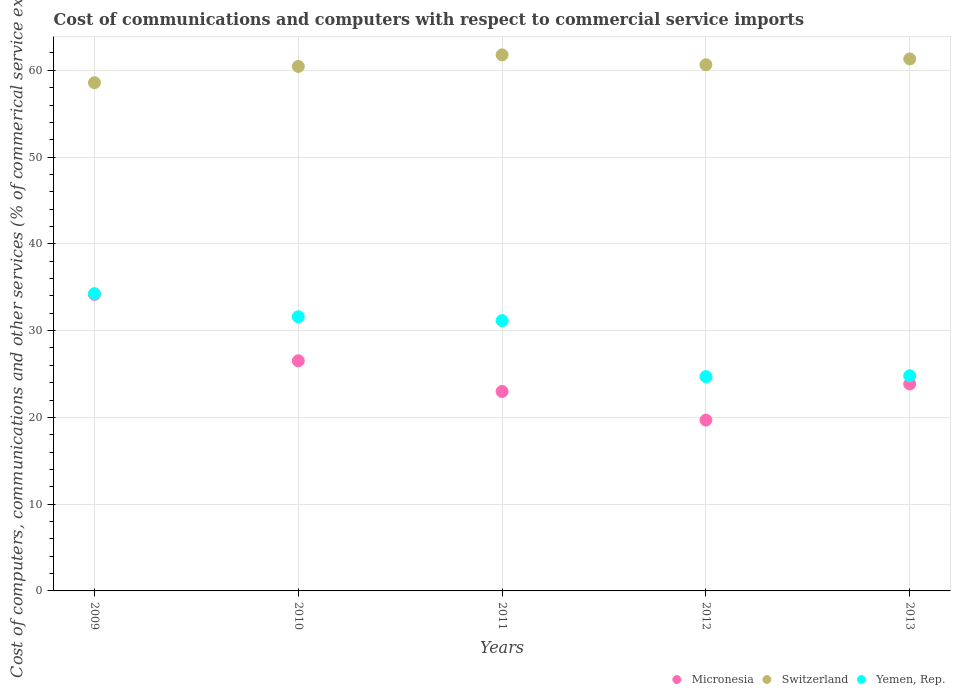How many different coloured dotlines are there?
Provide a short and direct response. 3. What is the cost of communications and computers in Yemen, Rep. in 2013?
Give a very brief answer. 24.8. Across all years, what is the maximum cost of communications and computers in Micronesia?
Offer a very short reply. 34.18. Across all years, what is the minimum cost of communications and computers in Micronesia?
Offer a very short reply. 19.69. In which year was the cost of communications and computers in Switzerland minimum?
Make the answer very short. 2009. What is the total cost of communications and computers in Micronesia in the graph?
Give a very brief answer. 127.21. What is the difference between the cost of communications and computers in Yemen, Rep. in 2009 and that in 2010?
Provide a succinct answer. 2.66. What is the difference between the cost of communications and computers in Switzerland in 2013 and the cost of communications and computers in Micronesia in 2010?
Offer a terse response. 34.79. What is the average cost of communications and computers in Micronesia per year?
Provide a short and direct response. 25.44. In the year 2010, what is the difference between the cost of communications and computers in Micronesia and cost of communications and computers in Yemen, Rep.?
Provide a short and direct response. -5.08. What is the ratio of the cost of communications and computers in Micronesia in 2011 to that in 2013?
Offer a very short reply. 0.96. What is the difference between the highest and the second highest cost of communications and computers in Switzerland?
Your answer should be compact. 0.47. What is the difference between the highest and the lowest cost of communications and computers in Yemen, Rep.?
Keep it short and to the point. 9.56. In how many years, is the cost of communications and computers in Yemen, Rep. greater than the average cost of communications and computers in Yemen, Rep. taken over all years?
Ensure brevity in your answer.  3. Is the cost of communications and computers in Switzerland strictly greater than the cost of communications and computers in Micronesia over the years?
Keep it short and to the point. Yes. Is the cost of communications and computers in Micronesia strictly less than the cost of communications and computers in Switzerland over the years?
Provide a short and direct response. Yes. How many years are there in the graph?
Your answer should be compact. 5. Are the values on the major ticks of Y-axis written in scientific E-notation?
Your answer should be compact. No. Does the graph contain grids?
Your answer should be compact. Yes. Where does the legend appear in the graph?
Provide a succinct answer. Bottom right. How are the legend labels stacked?
Make the answer very short. Horizontal. What is the title of the graph?
Your answer should be very brief. Cost of communications and computers with respect to commercial service imports. What is the label or title of the X-axis?
Keep it short and to the point. Years. What is the label or title of the Y-axis?
Your answer should be compact. Cost of computers, communications and other services (% of commerical service exports). What is the Cost of computers, communications and other services (% of commerical service exports) of Micronesia in 2009?
Provide a short and direct response. 34.18. What is the Cost of computers, communications and other services (% of commerical service exports) in Switzerland in 2009?
Offer a terse response. 58.57. What is the Cost of computers, communications and other services (% of commerical service exports) of Yemen, Rep. in 2009?
Ensure brevity in your answer.  34.26. What is the Cost of computers, communications and other services (% of commerical service exports) of Micronesia in 2010?
Your answer should be very brief. 26.52. What is the Cost of computers, communications and other services (% of commerical service exports) in Switzerland in 2010?
Your answer should be very brief. 60.44. What is the Cost of computers, communications and other services (% of commerical service exports) in Yemen, Rep. in 2010?
Your response must be concise. 31.6. What is the Cost of computers, communications and other services (% of commerical service exports) of Micronesia in 2011?
Your response must be concise. 22.98. What is the Cost of computers, communications and other services (% of commerical service exports) of Switzerland in 2011?
Offer a terse response. 61.78. What is the Cost of computers, communications and other services (% of commerical service exports) in Yemen, Rep. in 2011?
Provide a short and direct response. 31.15. What is the Cost of computers, communications and other services (% of commerical service exports) in Micronesia in 2012?
Ensure brevity in your answer.  19.69. What is the Cost of computers, communications and other services (% of commerical service exports) of Switzerland in 2012?
Keep it short and to the point. 60.64. What is the Cost of computers, communications and other services (% of commerical service exports) in Yemen, Rep. in 2012?
Provide a short and direct response. 24.7. What is the Cost of computers, communications and other services (% of commerical service exports) in Micronesia in 2013?
Your response must be concise. 23.84. What is the Cost of computers, communications and other services (% of commerical service exports) in Switzerland in 2013?
Make the answer very short. 61.31. What is the Cost of computers, communications and other services (% of commerical service exports) of Yemen, Rep. in 2013?
Offer a terse response. 24.8. Across all years, what is the maximum Cost of computers, communications and other services (% of commerical service exports) in Micronesia?
Your response must be concise. 34.18. Across all years, what is the maximum Cost of computers, communications and other services (% of commerical service exports) in Switzerland?
Provide a short and direct response. 61.78. Across all years, what is the maximum Cost of computers, communications and other services (% of commerical service exports) of Yemen, Rep.?
Your response must be concise. 34.26. Across all years, what is the minimum Cost of computers, communications and other services (% of commerical service exports) in Micronesia?
Offer a very short reply. 19.69. Across all years, what is the minimum Cost of computers, communications and other services (% of commerical service exports) of Switzerland?
Offer a terse response. 58.57. Across all years, what is the minimum Cost of computers, communications and other services (% of commerical service exports) of Yemen, Rep.?
Give a very brief answer. 24.7. What is the total Cost of computers, communications and other services (% of commerical service exports) in Micronesia in the graph?
Your response must be concise. 127.21. What is the total Cost of computers, communications and other services (% of commerical service exports) of Switzerland in the graph?
Your answer should be very brief. 302.74. What is the total Cost of computers, communications and other services (% of commerical service exports) in Yemen, Rep. in the graph?
Offer a terse response. 146.49. What is the difference between the Cost of computers, communications and other services (% of commerical service exports) in Micronesia in 2009 and that in 2010?
Give a very brief answer. 7.65. What is the difference between the Cost of computers, communications and other services (% of commerical service exports) of Switzerland in 2009 and that in 2010?
Keep it short and to the point. -1.88. What is the difference between the Cost of computers, communications and other services (% of commerical service exports) of Yemen, Rep. in 2009 and that in 2010?
Provide a short and direct response. 2.66. What is the difference between the Cost of computers, communications and other services (% of commerical service exports) of Micronesia in 2009 and that in 2011?
Provide a short and direct response. 11.19. What is the difference between the Cost of computers, communications and other services (% of commerical service exports) in Switzerland in 2009 and that in 2011?
Ensure brevity in your answer.  -3.21. What is the difference between the Cost of computers, communications and other services (% of commerical service exports) in Yemen, Rep. in 2009 and that in 2011?
Your response must be concise. 3.11. What is the difference between the Cost of computers, communications and other services (% of commerical service exports) of Micronesia in 2009 and that in 2012?
Your answer should be very brief. 14.49. What is the difference between the Cost of computers, communications and other services (% of commerical service exports) in Switzerland in 2009 and that in 2012?
Offer a very short reply. -2.07. What is the difference between the Cost of computers, communications and other services (% of commerical service exports) in Yemen, Rep. in 2009 and that in 2012?
Keep it short and to the point. 9.56. What is the difference between the Cost of computers, communications and other services (% of commerical service exports) in Micronesia in 2009 and that in 2013?
Provide a succinct answer. 10.33. What is the difference between the Cost of computers, communications and other services (% of commerical service exports) in Switzerland in 2009 and that in 2013?
Give a very brief answer. -2.74. What is the difference between the Cost of computers, communications and other services (% of commerical service exports) in Yemen, Rep. in 2009 and that in 2013?
Provide a short and direct response. 9.46. What is the difference between the Cost of computers, communications and other services (% of commerical service exports) in Micronesia in 2010 and that in 2011?
Keep it short and to the point. 3.54. What is the difference between the Cost of computers, communications and other services (% of commerical service exports) of Switzerland in 2010 and that in 2011?
Provide a short and direct response. -1.34. What is the difference between the Cost of computers, communications and other services (% of commerical service exports) in Yemen, Rep. in 2010 and that in 2011?
Give a very brief answer. 0.45. What is the difference between the Cost of computers, communications and other services (% of commerical service exports) of Micronesia in 2010 and that in 2012?
Your response must be concise. 6.83. What is the difference between the Cost of computers, communications and other services (% of commerical service exports) of Switzerland in 2010 and that in 2012?
Your answer should be compact. -0.2. What is the difference between the Cost of computers, communications and other services (% of commerical service exports) in Yemen, Rep. in 2010 and that in 2012?
Ensure brevity in your answer.  6.9. What is the difference between the Cost of computers, communications and other services (% of commerical service exports) in Micronesia in 2010 and that in 2013?
Provide a short and direct response. 2.68. What is the difference between the Cost of computers, communications and other services (% of commerical service exports) in Switzerland in 2010 and that in 2013?
Keep it short and to the point. -0.86. What is the difference between the Cost of computers, communications and other services (% of commerical service exports) in Yemen, Rep. in 2010 and that in 2013?
Give a very brief answer. 6.8. What is the difference between the Cost of computers, communications and other services (% of commerical service exports) in Micronesia in 2011 and that in 2012?
Give a very brief answer. 3.3. What is the difference between the Cost of computers, communications and other services (% of commerical service exports) of Switzerland in 2011 and that in 2012?
Give a very brief answer. 1.14. What is the difference between the Cost of computers, communications and other services (% of commerical service exports) in Yemen, Rep. in 2011 and that in 2012?
Offer a terse response. 6.45. What is the difference between the Cost of computers, communications and other services (% of commerical service exports) in Micronesia in 2011 and that in 2013?
Offer a terse response. -0.86. What is the difference between the Cost of computers, communications and other services (% of commerical service exports) in Switzerland in 2011 and that in 2013?
Offer a very short reply. 0.47. What is the difference between the Cost of computers, communications and other services (% of commerical service exports) in Yemen, Rep. in 2011 and that in 2013?
Offer a terse response. 6.35. What is the difference between the Cost of computers, communications and other services (% of commerical service exports) in Micronesia in 2012 and that in 2013?
Provide a short and direct response. -4.16. What is the difference between the Cost of computers, communications and other services (% of commerical service exports) in Switzerland in 2012 and that in 2013?
Your answer should be very brief. -0.67. What is the difference between the Cost of computers, communications and other services (% of commerical service exports) in Yemen, Rep. in 2012 and that in 2013?
Your answer should be compact. -0.1. What is the difference between the Cost of computers, communications and other services (% of commerical service exports) of Micronesia in 2009 and the Cost of computers, communications and other services (% of commerical service exports) of Switzerland in 2010?
Ensure brevity in your answer.  -26.27. What is the difference between the Cost of computers, communications and other services (% of commerical service exports) in Micronesia in 2009 and the Cost of computers, communications and other services (% of commerical service exports) in Yemen, Rep. in 2010?
Provide a succinct answer. 2.58. What is the difference between the Cost of computers, communications and other services (% of commerical service exports) in Switzerland in 2009 and the Cost of computers, communications and other services (% of commerical service exports) in Yemen, Rep. in 2010?
Offer a very short reply. 26.97. What is the difference between the Cost of computers, communications and other services (% of commerical service exports) of Micronesia in 2009 and the Cost of computers, communications and other services (% of commerical service exports) of Switzerland in 2011?
Your response must be concise. -27.61. What is the difference between the Cost of computers, communications and other services (% of commerical service exports) in Micronesia in 2009 and the Cost of computers, communications and other services (% of commerical service exports) in Yemen, Rep. in 2011?
Your response must be concise. 3.03. What is the difference between the Cost of computers, communications and other services (% of commerical service exports) of Switzerland in 2009 and the Cost of computers, communications and other services (% of commerical service exports) of Yemen, Rep. in 2011?
Provide a short and direct response. 27.42. What is the difference between the Cost of computers, communications and other services (% of commerical service exports) in Micronesia in 2009 and the Cost of computers, communications and other services (% of commerical service exports) in Switzerland in 2012?
Offer a very short reply. -26.46. What is the difference between the Cost of computers, communications and other services (% of commerical service exports) in Micronesia in 2009 and the Cost of computers, communications and other services (% of commerical service exports) in Yemen, Rep. in 2012?
Your answer should be compact. 9.48. What is the difference between the Cost of computers, communications and other services (% of commerical service exports) of Switzerland in 2009 and the Cost of computers, communications and other services (% of commerical service exports) of Yemen, Rep. in 2012?
Ensure brevity in your answer.  33.87. What is the difference between the Cost of computers, communications and other services (% of commerical service exports) of Micronesia in 2009 and the Cost of computers, communications and other services (% of commerical service exports) of Switzerland in 2013?
Your response must be concise. -27.13. What is the difference between the Cost of computers, communications and other services (% of commerical service exports) in Micronesia in 2009 and the Cost of computers, communications and other services (% of commerical service exports) in Yemen, Rep. in 2013?
Keep it short and to the point. 9.38. What is the difference between the Cost of computers, communications and other services (% of commerical service exports) in Switzerland in 2009 and the Cost of computers, communications and other services (% of commerical service exports) in Yemen, Rep. in 2013?
Give a very brief answer. 33.77. What is the difference between the Cost of computers, communications and other services (% of commerical service exports) of Micronesia in 2010 and the Cost of computers, communications and other services (% of commerical service exports) of Switzerland in 2011?
Provide a short and direct response. -35.26. What is the difference between the Cost of computers, communications and other services (% of commerical service exports) in Micronesia in 2010 and the Cost of computers, communications and other services (% of commerical service exports) in Yemen, Rep. in 2011?
Offer a very short reply. -4.63. What is the difference between the Cost of computers, communications and other services (% of commerical service exports) of Switzerland in 2010 and the Cost of computers, communications and other services (% of commerical service exports) of Yemen, Rep. in 2011?
Keep it short and to the point. 29.3. What is the difference between the Cost of computers, communications and other services (% of commerical service exports) in Micronesia in 2010 and the Cost of computers, communications and other services (% of commerical service exports) in Switzerland in 2012?
Give a very brief answer. -34.12. What is the difference between the Cost of computers, communications and other services (% of commerical service exports) in Micronesia in 2010 and the Cost of computers, communications and other services (% of commerical service exports) in Yemen, Rep. in 2012?
Provide a short and direct response. 1.83. What is the difference between the Cost of computers, communications and other services (% of commerical service exports) in Switzerland in 2010 and the Cost of computers, communications and other services (% of commerical service exports) in Yemen, Rep. in 2012?
Offer a very short reply. 35.75. What is the difference between the Cost of computers, communications and other services (% of commerical service exports) of Micronesia in 2010 and the Cost of computers, communications and other services (% of commerical service exports) of Switzerland in 2013?
Offer a terse response. -34.79. What is the difference between the Cost of computers, communications and other services (% of commerical service exports) in Micronesia in 2010 and the Cost of computers, communications and other services (% of commerical service exports) in Yemen, Rep. in 2013?
Keep it short and to the point. 1.72. What is the difference between the Cost of computers, communications and other services (% of commerical service exports) in Switzerland in 2010 and the Cost of computers, communications and other services (% of commerical service exports) in Yemen, Rep. in 2013?
Make the answer very short. 35.65. What is the difference between the Cost of computers, communications and other services (% of commerical service exports) in Micronesia in 2011 and the Cost of computers, communications and other services (% of commerical service exports) in Switzerland in 2012?
Offer a very short reply. -37.66. What is the difference between the Cost of computers, communications and other services (% of commerical service exports) in Micronesia in 2011 and the Cost of computers, communications and other services (% of commerical service exports) in Yemen, Rep. in 2012?
Provide a short and direct response. -1.71. What is the difference between the Cost of computers, communications and other services (% of commerical service exports) in Switzerland in 2011 and the Cost of computers, communications and other services (% of commerical service exports) in Yemen, Rep. in 2012?
Provide a short and direct response. 37.09. What is the difference between the Cost of computers, communications and other services (% of commerical service exports) in Micronesia in 2011 and the Cost of computers, communications and other services (% of commerical service exports) in Switzerland in 2013?
Keep it short and to the point. -38.32. What is the difference between the Cost of computers, communications and other services (% of commerical service exports) in Micronesia in 2011 and the Cost of computers, communications and other services (% of commerical service exports) in Yemen, Rep. in 2013?
Make the answer very short. -1.81. What is the difference between the Cost of computers, communications and other services (% of commerical service exports) in Switzerland in 2011 and the Cost of computers, communications and other services (% of commerical service exports) in Yemen, Rep. in 2013?
Ensure brevity in your answer.  36.98. What is the difference between the Cost of computers, communications and other services (% of commerical service exports) of Micronesia in 2012 and the Cost of computers, communications and other services (% of commerical service exports) of Switzerland in 2013?
Offer a very short reply. -41.62. What is the difference between the Cost of computers, communications and other services (% of commerical service exports) in Micronesia in 2012 and the Cost of computers, communications and other services (% of commerical service exports) in Yemen, Rep. in 2013?
Offer a very short reply. -5.11. What is the difference between the Cost of computers, communications and other services (% of commerical service exports) in Switzerland in 2012 and the Cost of computers, communications and other services (% of commerical service exports) in Yemen, Rep. in 2013?
Keep it short and to the point. 35.84. What is the average Cost of computers, communications and other services (% of commerical service exports) of Micronesia per year?
Offer a very short reply. 25.44. What is the average Cost of computers, communications and other services (% of commerical service exports) in Switzerland per year?
Offer a very short reply. 60.55. What is the average Cost of computers, communications and other services (% of commerical service exports) of Yemen, Rep. per year?
Your response must be concise. 29.3. In the year 2009, what is the difference between the Cost of computers, communications and other services (% of commerical service exports) in Micronesia and Cost of computers, communications and other services (% of commerical service exports) in Switzerland?
Your answer should be compact. -24.39. In the year 2009, what is the difference between the Cost of computers, communications and other services (% of commerical service exports) in Micronesia and Cost of computers, communications and other services (% of commerical service exports) in Yemen, Rep.?
Your response must be concise. -0.08. In the year 2009, what is the difference between the Cost of computers, communications and other services (% of commerical service exports) in Switzerland and Cost of computers, communications and other services (% of commerical service exports) in Yemen, Rep.?
Ensure brevity in your answer.  24.31. In the year 2010, what is the difference between the Cost of computers, communications and other services (% of commerical service exports) of Micronesia and Cost of computers, communications and other services (% of commerical service exports) of Switzerland?
Keep it short and to the point. -33.92. In the year 2010, what is the difference between the Cost of computers, communications and other services (% of commerical service exports) in Micronesia and Cost of computers, communications and other services (% of commerical service exports) in Yemen, Rep.?
Keep it short and to the point. -5.08. In the year 2010, what is the difference between the Cost of computers, communications and other services (% of commerical service exports) of Switzerland and Cost of computers, communications and other services (% of commerical service exports) of Yemen, Rep.?
Your response must be concise. 28.85. In the year 2011, what is the difference between the Cost of computers, communications and other services (% of commerical service exports) in Micronesia and Cost of computers, communications and other services (% of commerical service exports) in Switzerland?
Provide a succinct answer. -38.8. In the year 2011, what is the difference between the Cost of computers, communications and other services (% of commerical service exports) of Micronesia and Cost of computers, communications and other services (% of commerical service exports) of Yemen, Rep.?
Your answer should be compact. -8.17. In the year 2011, what is the difference between the Cost of computers, communications and other services (% of commerical service exports) in Switzerland and Cost of computers, communications and other services (% of commerical service exports) in Yemen, Rep.?
Your answer should be compact. 30.63. In the year 2012, what is the difference between the Cost of computers, communications and other services (% of commerical service exports) of Micronesia and Cost of computers, communications and other services (% of commerical service exports) of Switzerland?
Offer a terse response. -40.95. In the year 2012, what is the difference between the Cost of computers, communications and other services (% of commerical service exports) of Micronesia and Cost of computers, communications and other services (% of commerical service exports) of Yemen, Rep.?
Offer a terse response. -5.01. In the year 2012, what is the difference between the Cost of computers, communications and other services (% of commerical service exports) in Switzerland and Cost of computers, communications and other services (% of commerical service exports) in Yemen, Rep.?
Keep it short and to the point. 35.94. In the year 2013, what is the difference between the Cost of computers, communications and other services (% of commerical service exports) in Micronesia and Cost of computers, communications and other services (% of commerical service exports) in Switzerland?
Provide a short and direct response. -37.46. In the year 2013, what is the difference between the Cost of computers, communications and other services (% of commerical service exports) of Micronesia and Cost of computers, communications and other services (% of commerical service exports) of Yemen, Rep.?
Your answer should be compact. -0.95. In the year 2013, what is the difference between the Cost of computers, communications and other services (% of commerical service exports) in Switzerland and Cost of computers, communications and other services (% of commerical service exports) in Yemen, Rep.?
Your answer should be very brief. 36.51. What is the ratio of the Cost of computers, communications and other services (% of commerical service exports) of Micronesia in 2009 to that in 2010?
Give a very brief answer. 1.29. What is the ratio of the Cost of computers, communications and other services (% of commerical service exports) in Switzerland in 2009 to that in 2010?
Your response must be concise. 0.97. What is the ratio of the Cost of computers, communications and other services (% of commerical service exports) in Yemen, Rep. in 2009 to that in 2010?
Provide a short and direct response. 1.08. What is the ratio of the Cost of computers, communications and other services (% of commerical service exports) of Micronesia in 2009 to that in 2011?
Offer a very short reply. 1.49. What is the ratio of the Cost of computers, communications and other services (% of commerical service exports) of Switzerland in 2009 to that in 2011?
Provide a succinct answer. 0.95. What is the ratio of the Cost of computers, communications and other services (% of commerical service exports) in Yemen, Rep. in 2009 to that in 2011?
Provide a succinct answer. 1.1. What is the ratio of the Cost of computers, communications and other services (% of commerical service exports) in Micronesia in 2009 to that in 2012?
Offer a very short reply. 1.74. What is the ratio of the Cost of computers, communications and other services (% of commerical service exports) of Switzerland in 2009 to that in 2012?
Offer a terse response. 0.97. What is the ratio of the Cost of computers, communications and other services (% of commerical service exports) of Yemen, Rep. in 2009 to that in 2012?
Ensure brevity in your answer.  1.39. What is the ratio of the Cost of computers, communications and other services (% of commerical service exports) of Micronesia in 2009 to that in 2013?
Offer a terse response. 1.43. What is the ratio of the Cost of computers, communications and other services (% of commerical service exports) in Switzerland in 2009 to that in 2013?
Your answer should be compact. 0.96. What is the ratio of the Cost of computers, communications and other services (% of commerical service exports) in Yemen, Rep. in 2009 to that in 2013?
Your answer should be very brief. 1.38. What is the ratio of the Cost of computers, communications and other services (% of commerical service exports) in Micronesia in 2010 to that in 2011?
Your answer should be very brief. 1.15. What is the ratio of the Cost of computers, communications and other services (% of commerical service exports) in Switzerland in 2010 to that in 2011?
Your answer should be compact. 0.98. What is the ratio of the Cost of computers, communications and other services (% of commerical service exports) of Yemen, Rep. in 2010 to that in 2011?
Make the answer very short. 1.01. What is the ratio of the Cost of computers, communications and other services (% of commerical service exports) in Micronesia in 2010 to that in 2012?
Provide a short and direct response. 1.35. What is the ratio of the Cost of computers, communications and other services (% of commerical service exports) of Switzerland in 2010 to that in 2012?
Your answer should be very brief. 1. What is the ratio of the Cost of computers, communications and other services (% of commerical service exports) in Yemen, Rep. in 2010 to that in 2012?
Your answer should be very brief. 1.28. What is the ratio of the Cost of computers, communications and other services (% of commerical service exports) in Micronesia in 2010 to that in 2013?
Your answer should be compact. 1.11. What is the ratio of the Cost of computers, communications and other services (% of commerical service exports) of Switzerland in 2010 to that in 2013?
Offer a terse response. 0.99. What is the ratio of the Cost of computers, communications and other services (% of commerical service exports) of Yemen, Rep. in 2010 to that in 2013?
Offer a terse response. 1.27. What is the ratio of the Cost of computers, communications and other services (% of commerical service exports) of Micronesia in 2011 to that in 2012?
Your response must be concise. 1.17. What is the ratio of the Cost of computers, communications and other services (% of commerical service exports) of Switzerland in 2011 to that in 2012?
Give a very brief answer. 1.02. What is the ratio of the Cost of computers, communications and other services (% of commerical service exports) of Yemen, Rep. in 2011 to that in 2012?
Offer a very short reply. 1.26. What is the ratio of the Cost of computers, communications and other services (% of commerical service exports) in Micronesia in 2011 to that in 2013?
Keep it short and to the point. 0.96. What is the ratio of the Cost of computers, communications and other services (% of commerical service exports) of Switzerland in 2011 to that in 2013?
Your answer should be compact. 1.01. What is the ratio of the Cost of computers, communications and other services (% of commerical service exports) of Yemen, Rep. in 2011 to that in 2013?
Your answer should be very brief. 1.26. What is the ratio of the Cost of computers, communications and other services (% of commerical service exports) of Micronesia in 2012 to that in 2013?
Give a very brief answer. 0.83. What is the ratio of the Cost of computers, communications and other services (% of commerical service exports) of Yemen, Rep. in 2012 to that in 2013?
Provide a short and direct response. 1. What is the difference between the highest and the second highest Cost of computers, communications and other services (% of commerical service exports) in Micronesia?
Your response must be concise. 7.65. What is the difference between the highest and the second highest Cost of computers, communications and other services (% of commerical service exports) of Switzerland?
Ensure brevity in your answer.  0.47. What is the difference between the highest and the second highest Cost of computers, communications and other services (% of commerical service exports) of Yemen, Rep.?
Your answer should be very brief. 2.66. What is the difference between the highest and the lowest Cost of computers, communications and other services (% of commerical service exports) in Micronesia?
Your answer should be compact. 14.49. What is the difference between the highest and the lowest Cost of computers, communications and other services (% of commerical service exports) of Switzerland?
Your answer should be compact. 3.21. What is the difference between the highest and the lowest Cost of computers, communications and other services (% of commerical service exports) in Yemen, Rep.?
Keep it short and to the point. 9.56. 